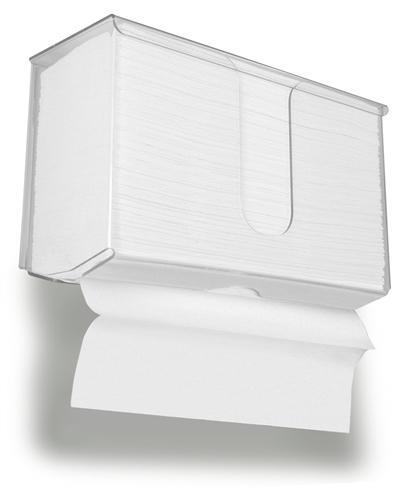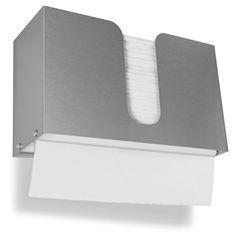The first image is the image on the left, the second image is the image on the right. Considering the images on both sides, is "The right image shows an opaque gray wall-mount dispenser with a white paper towel hanging below it." valid? Answer yes or no. Yes. The first image is the image on the left, the second image is the image on the right. For the images shown, is this caption "White paper is coming out of a grey dispenser in the image on the right." true? Answer yes or no. Yes. 